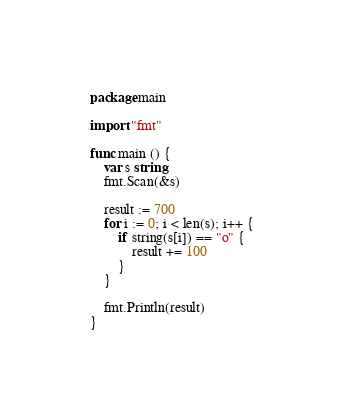Convert code to text. <code><loc_0><loc_0><loc_500><loc_500><_Go_>package main

import "fmt"

func main () {
	var s string
	fmt.Scan(&s)

	result := 700
	for i := 0; i < len(s); i++ {
		if string(s[i]) == "o" {
			result += 100
		}
	}

	fmt.Println(result)
}</code> 